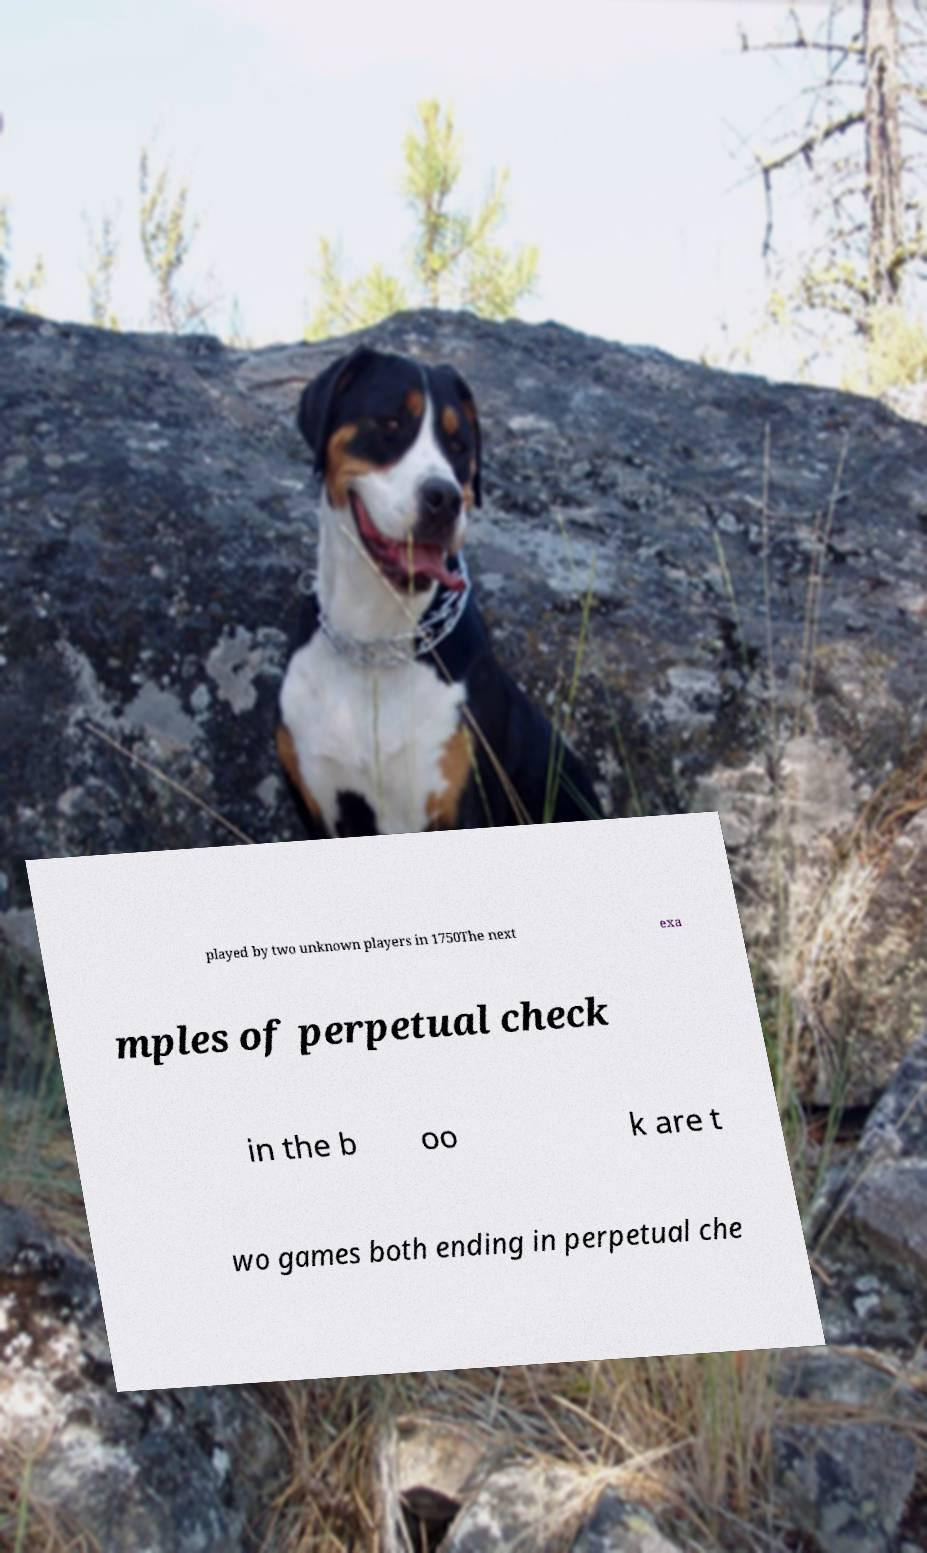What messages or text are displayed in this image? I need them in a readable, typed format. played by two unknown players in 1750The next exa mples of perpetual check in the b oo k are t wo games both ending in perpetual che 